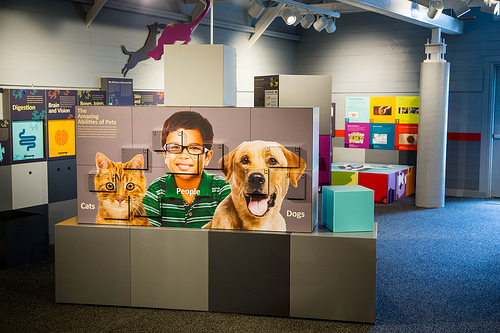<image>
Is the dog on the wall? Yes. Looking at the image, I can see the dog is positioned on top of the wall, with the wall providing support. 